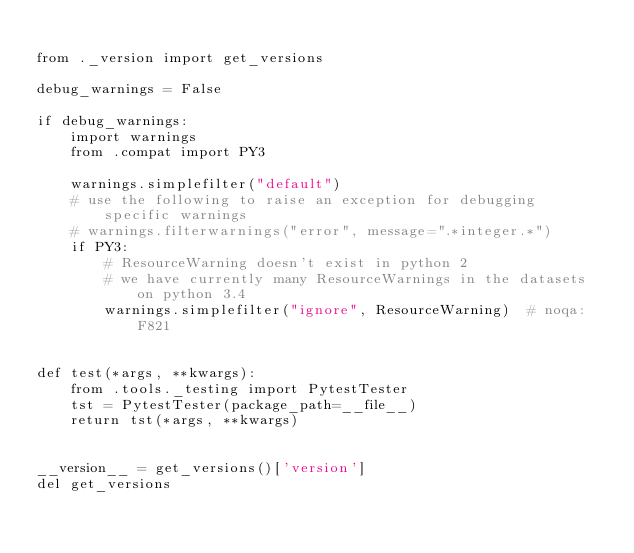Convert code to text. <code><loc_0><loc_0><loc_500><loc_500><_Python_>
from ._version import get_versions

debug_warnings = False

if debug_warnings:
    import warnings
    from .compat import PY3

    warnings.simplefilter("default")
    # use the following to raise an exception for debugging specific warnings
    # warnings.filterwarnings("error", message=".*integer.*")
    if PY3:
        # ResourceWarning doesn't exist in python 2
        # we have currently many ResourceWarnings in the datasets on python 3.4
        warnings.simplefilter("ignore", ResourceWarning)  # noqa:F821


def test(*args, **kwargs):
    from .tools._testing import PytestTester
    tst = PytestTester(package_path=__file__)
    return tst(*args, **kwargs)


__version__ = get_versions()['version']
del get_versions
</code> 